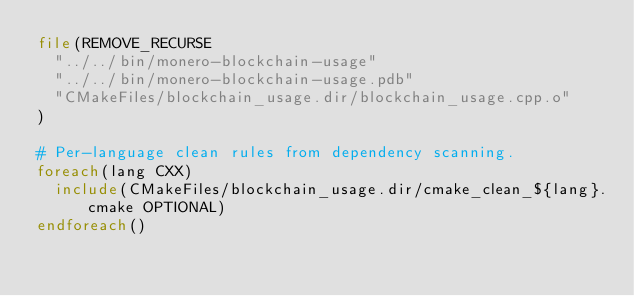Convert code to text. <code><loc_0><loc_0><loc_500><loc_500><_CMake_>file(REMOVE_RECURSE
  "../../bin/monero-blockchain-usage"
  "../../bin/monero-blockchain-usage.pdb"
  "CMakeFiles/blockchain_usage.dir/blockchain_usage.cpp.o"
)

# Per-language clean rules from dependency scanning.
foreach(lang CXX)
  include(CMakeFiles/blockchain_usage.dir/cmake_clean_${lang}.cmake OPTIONAL)
endforeach()
</code> 